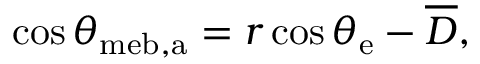<formula> <loc_0><loc_0><loc_500><loc_500>\cos \theta _ { m e b , a } = r \cos \theta _ { e } - \overline { D } ,</formula> 